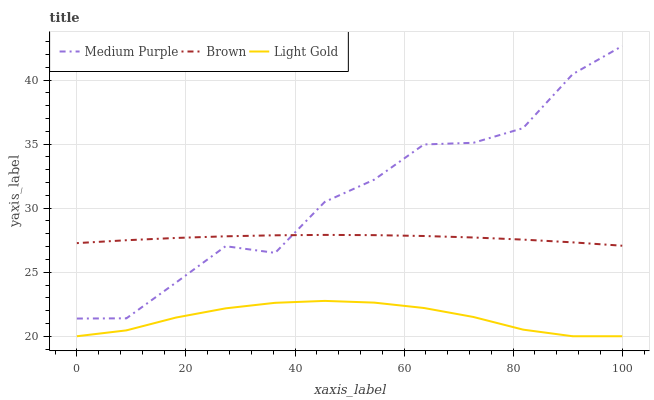Does Light Gold have the minimum area under the curve?
Answer yes or no. Yes. Does Medium Purple have the maximum area under the curve?
Answer yes or no. Yes. Does Brown have the minimum area under the curve?
Answer yes or no. No. Does Brown have the maximum area under the curve?
Answer yes or no. No. Is Brown the smoothest?
Answer yes or no. Yes. Is Medium Purple the roughest?
Answer yes or no. Yes. Is Light Gold the smoothest?
Answer yes or no. No. Is Light Gold the roughest?
Answer yes or no. No. Does Light Gold have the lowest value?
Answer yes or no. Yes. Does Brown have the lowest value?
Answer yes or no. No. Does Medium Purple have the highest value?
Answer yes or no. Yes. Does Brown have the highest value?
Answer yes or no. No. Is Light Gold less than Brown?
Answer yes or no. Yes. Is Medium Purple greater than Light Gold?
Answer yes or no. Yes. Does Medium Purple intersect Brown?
Answer yes or no. Yes. Is Medium Purple less than Brown?
Answer yes or no. No. Is Medium Purple greater than Brown?
Answer yes or no. No. Does Light Gold intersect Brown?
Answer yes or no. No. 